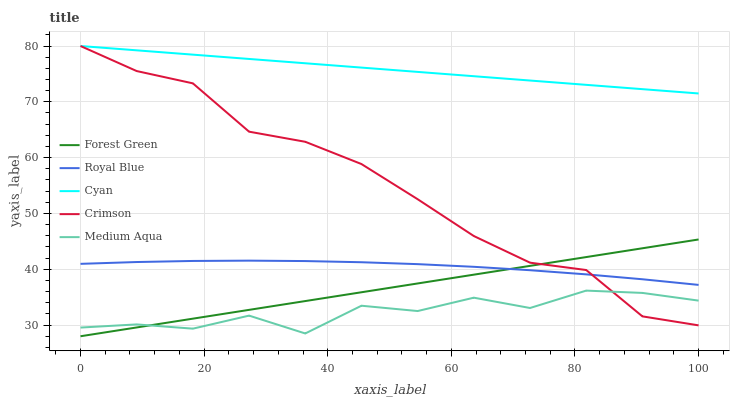Does Medium Aqua have the minimum area under the curve?
Answer yes or no. Yes. Does Cyan have the maximum area under the curve?
Answer yes or no. Yes. Does Royal Blue have the minimum area under the curve?
Answer yes or no. No. Does Royal Blue have the maximum area under the curve?
Answer yes or no. No. Is Forest Green the smoothest?
Answer yes or no. Yes. Is Medium Aqua the roughest?
Answer yes or no. Yes. Is Royal Blue the smoothest?
Answer yes or no. No. Is Royal Blue the roughest?
Answer yes or no. No. Does Royal Blue have the lowest value?
Answer yes or no. No. Does Cyan have the highest value?
Answer yes or no. Yes. Does Royal Blue have the highest value?
Answer yes or no. No. Is Medium Aqua less than Cyan?
Answer yes or no. Yes. Is Royal Blue greater than Medium Aqua?
Answer yes or no. Yes. Does Medium Aqua intersect Cyan?
Answer yes or no. No. 